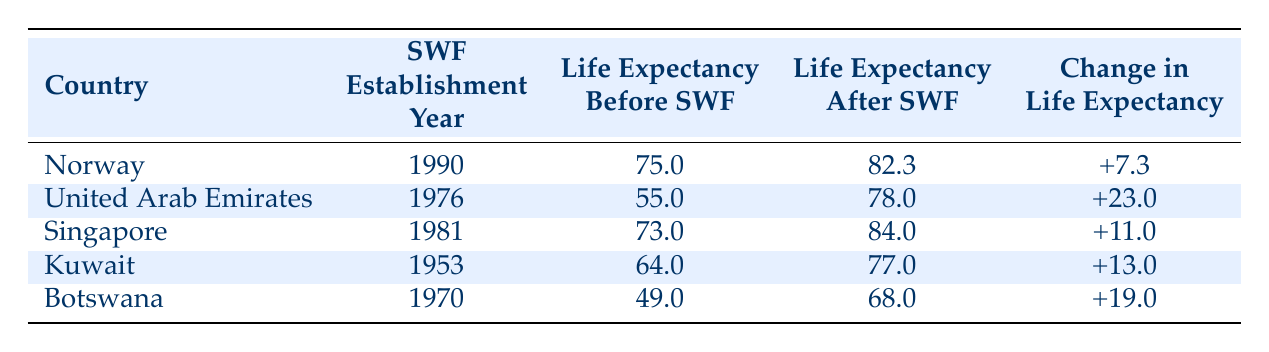What is the life expectancy in Kuwait before the establishment of the sovereign wealth fund? According to the table, Kuwait's life expectancy before the establishment of the sovereign wealth fund is listed under the respective column. The value is 64.0.
Answer: 64.0 What was the change in life expectancy for Norway after the establishment of its sovereign wealth fund? To find the change in life expectancy for Norway, we look at the value in the "Change in Life Expectancy" column, which indicates +7.3.
Answer: +7.3 Which country has the highest life expectancy after the establishment of its sovereign wealth fund? By examining the "Life Expectancy After SWF" column, the values indicate that Singapore has the highest life expectancy at 84.0.
Answer: Singapore Is it true that Botswana had a life expectancy of over 60 before its sovereign wealth fund was established? The table shows Botswana's life expectancy before the establishment of the sovereign wealth fund as 49.0, which is below 60, so the statement is false.
Answer: False What is the average increase in life expectancy across all listed countries after the establishment of their sovereign wealth funds? To find the average increase, sum the changes in life expectancy: 7.3 + 23.0 + 11.0 + 13.0 + 19.0 = 73.3. Then, divide by the number of countries (5). So, the average increase is 73.3 / 5 = 14.66.
Answer: 14.66 What was the life expectancy in the United Arab Emirates before and after the establishment of the SWF? The table shows that the life expectancy before the establishment was 55.0, and after it was 78.0. Thus, the entire range can be noted as 55.0 before and 78.0 after.
Answer: 55.0 before and 78.0 after Which country improved its life expectancy by the least amount after establishing its sovereign wealth fund? By comparing the "Change in Life Expectancy" column, we see that Norway improved by +7.3, which is the smallest change among the countries listed.
Answer: Norway Does Kuwait have a higher life expectancy after the establishment of its sovereign wealth fund than Botswana? Comparing the "Life Expectancy After SWF" values, Kuwait at 77.0 is higher than Botswana at 68.0, which makes the statement true.
Answer: True What was the year of establishment for the sovereign wealth fund in Singapore? Referring to the respective column, Singapore's sovereign wealth fund was established in the year 1981.
Answer: 1981 